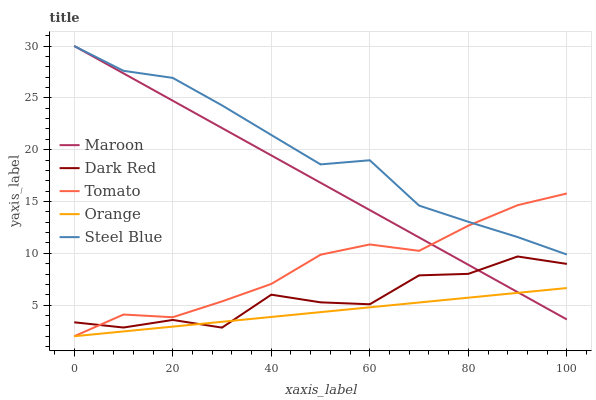Does Dark Red have the minimum area under the curve?
Answer yes or no. No. Does Dark Red have the maximum area under the curve?
Answer yes or no. No. Is Dark Red the smoothest?
Answer yes or no. No. Is Orange the roughest?
Answer yes or no. No. Does Dark Red have the lowest value?
Answer yes or no. No. Does Dark Red have the highest value?
Answer yes or no. No. Is Dark Red less than Steel Blue?
Answer yes or no. Yes. Is Steel Blue greater than Orange?
Answer yes or no. Yes. Does Dark Red intersect Steel Blue?
Answer yes or no. No. 